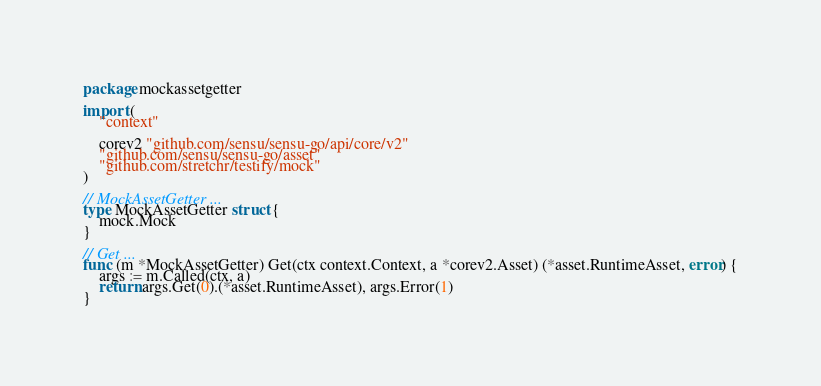<code> <loc_0><loc_0><loc_500><loc_500><_Go_>package mockassetgetter

import (
	"context"

	corev2 "github.com/sensu/sensu-go/api/core/v2"
	"github.com/sensu/sensu-go/asset"
	"github.com/stretchr/testify/mock"
)

// MockAssetGetter ...
type MockAssetGetter struct {
	mock.Mock
}

// Get ...
func (m *MockAssetGetter) Get(ctx context.Context, a *corev2.Asset) (*asset.RuntimeAsset, error) {
	args := m.Called(ctx, a)
	return args.Get(0).(*asset.RuntimeAsset), args.Error(1)
}
</code> 